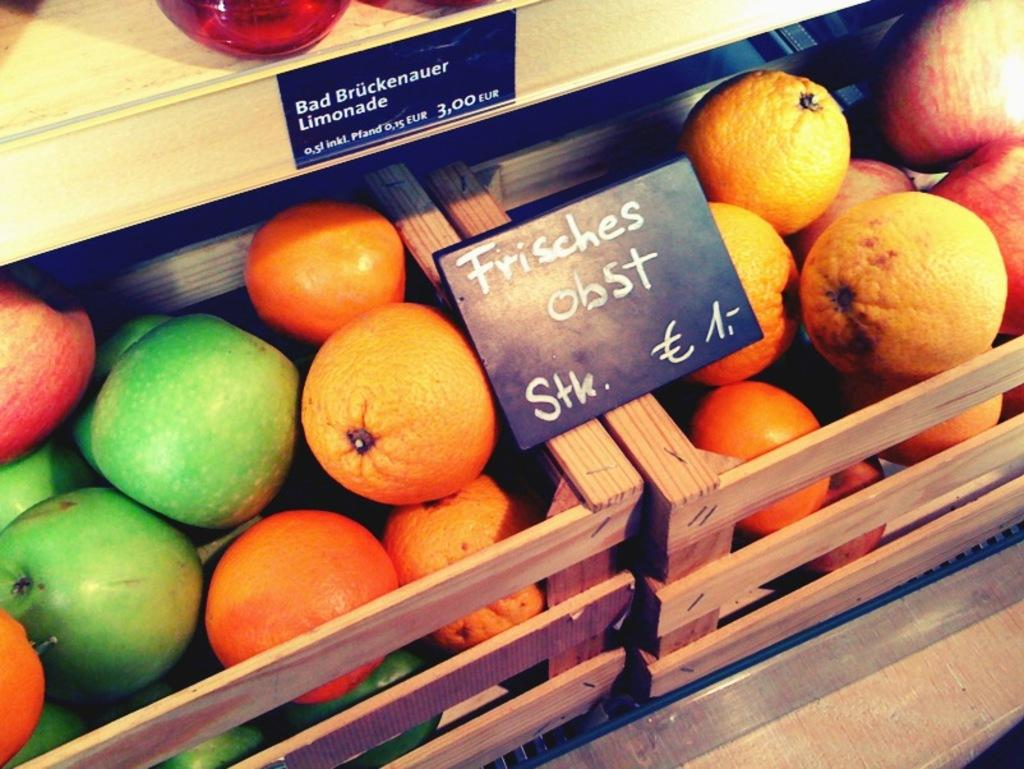What type of food is present in the wooden baskets in the image? There are fruits in the wooden baskets in the image. What colors can be seen among the fruits? The fruits are in green, orange, and red colors. What material is used for the baskets? The baskets are made of wood. What else can be seen in the image besides the fruits and baskets? There are boards visible in the image. What is written on the boards? Something is written on the boards, but the specific text cannot be determined from the image. What type of pencil is being used by the spy in the image? There is no spy or pencil present in the image. What answer is being written on the board in the image? There is no answer being written on the board in the image, as the specific text cannot be determined from the image. 